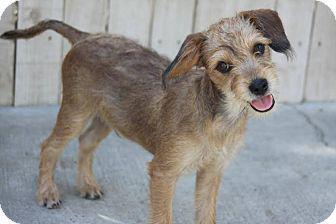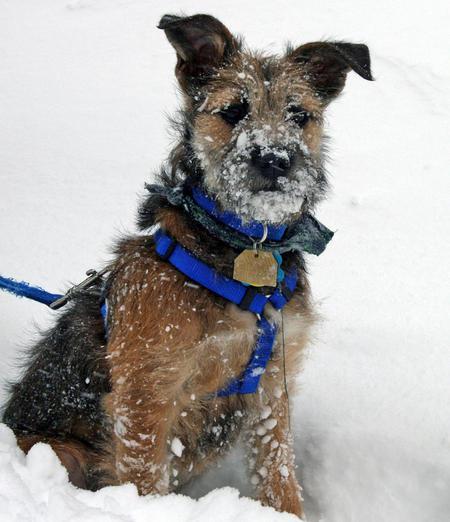The first image is the image on the left, the second image is the image on the right. Given the left and right images, does the statement "A dog is on carpet in one picture and on a blanket in the other picture." hold true? Answer yes or no. No. The first image is the image on the left, the second image is the image on the right. For the images displayed, is the sentence "The dog in the right image has a green leash." factually correct? Answer yes or no. No. 